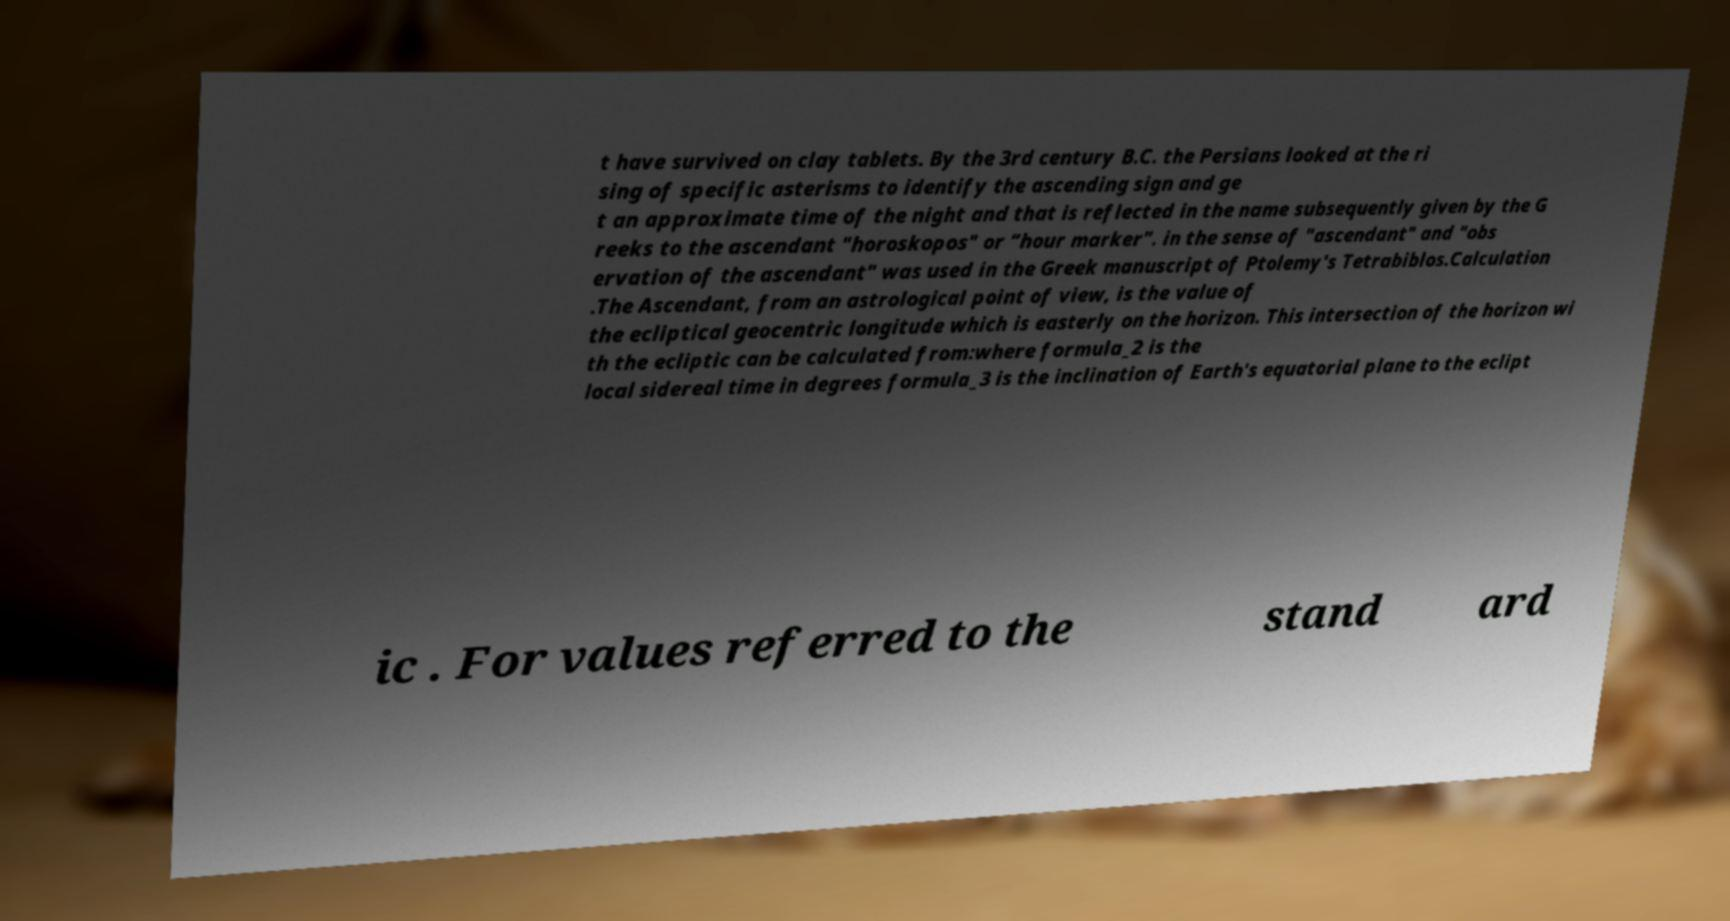Can you accurately transcribe the text from the provided image for me? t have survived on clay tablets. By the 3rd century B.C. the Persians looked at the ri sing of specific asterisms to identify the ascending sign and ge t an approximate time of the night and that is reflected in the name subsequently given by the G reeks to the ascendant "horoskopos" or “hour marker”. in the sense of "ascendant" and "obs ervation of the ascendant" was used in the Greek manuscript of Ptolemy's Tetrabiblos.Calculation .The Ascendant, from an astrological point of view, is the value of the ecliptical geocentric longitude which is easterly on the horizon. This intersection of the horizon wi th the ecliptic can be calculated from:where formula_2 is the local sidereal time in degrees formula_3 is the inclination of Earth's equatorial plane to the eclipt ic . For values referred to the stand ard 